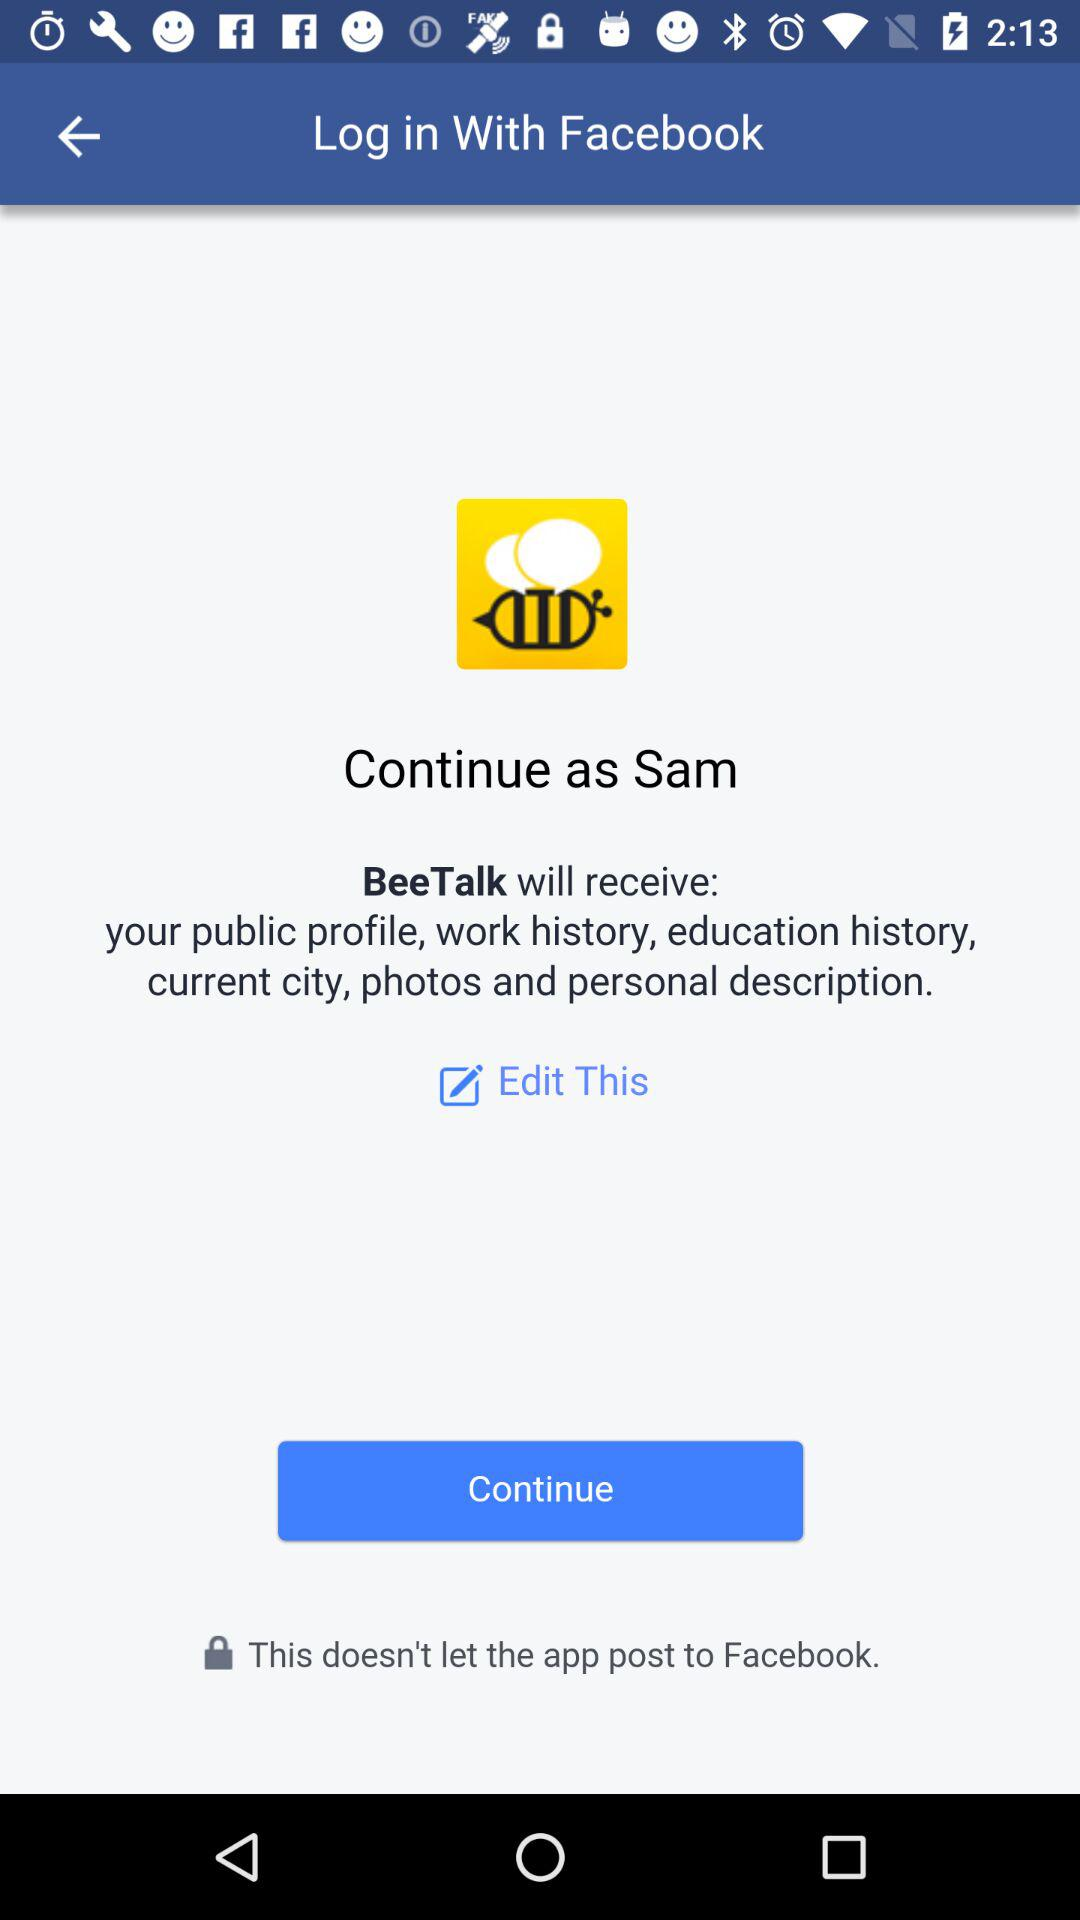What application is asking for permission? The application that is asking for permission is "BeeTalk". 